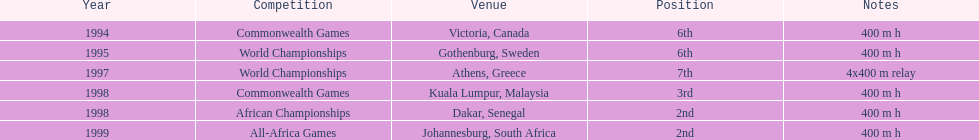Other than 1999, what year did ken harnden win second place? 1998. I'm looking to parse the entire table for insights. Could you assist me with that? {'header': ['Year', 'Competition', 'Venue', 'Position', 'Notes'], 'rows': [['1994', 'Commonwealth Games', 'Victoria, Canada', '6th', '400 m h'], ['1995', 'World Championships', 'Gothenburg, Sweden', '6th', '400 m h'], ['1997', 'World Championships', 'Athens, Greece', '7th', '4x400 m relay'], ['1998', 'Commonwealth Games', 'Kuala Lumpur, Malaysia', '3rd', '400 m h'], ['1998', 'African Championships', 'Dakar, Senegal', '2nd', '400 m h'], ['1999', 'All-Africa Games', 'Johannesburg, South Africa', '2nd', '400 m h']]} 